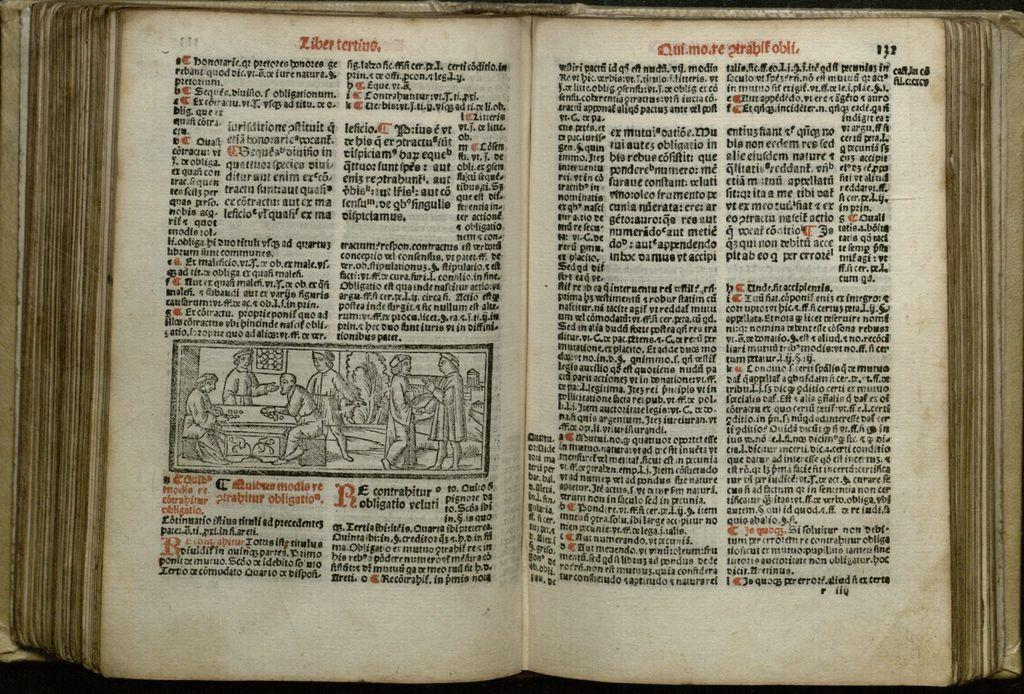<image>
Share a concise interpretation of the image provided. An open book on a table written in a foreign language 